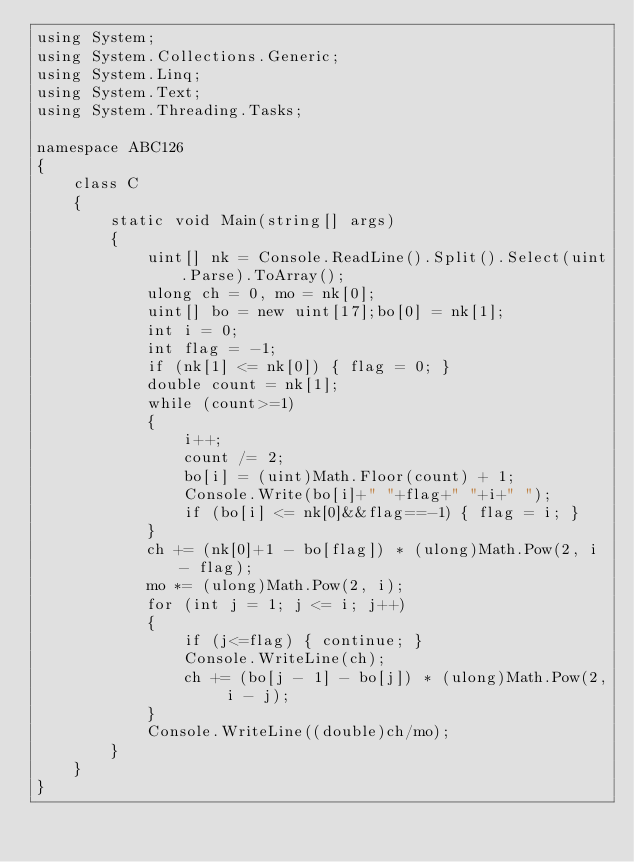<code> <loc_0><loc_0><loc_500><loc_500><_C#_>using System;
using System.Collections.Generic;
using System.Linq;
using System.Text;
using System.Threading.Tasks;

namespace ABC126
{
    class C
    {
        static void Main(string[] args)
        {
            uint[] nk = Console.ReadLine().Split().Select(uint.Parse).ToArray();
            ulong ch = 0, mo = nk[0];
            uint[] bo = new uint[17];bo[0] = nk[1];
            int i = 0;
            int flag = -1;
            if (nk[1] <= nk[0]) { flag = 0; }
            double count = nk[1];
            while (count>=1)
            {
                i++;
                count /= 2;
                bo[i] = (uint)Math.Floor(count) + 1;
                Console.Write(bo[i]+" "+flag+" "+i+" ");
                if (bo[i] <= nk[0]&&flag==-1) { flag = i; }
            }
            ch += (nk[0]+1 - bo[flag]) * (ulong)Math.Pow(2, i - flag);
            mo *= (ulong)Math.Pow(2, i);
            for (int j = 1; j <= i; j++)
            {
                if (j<=flag) { continue; }
                Console.WriteLine(ch);
                ch += (bo[j - 1] - bo[j]) * (ulong)Math.Pow(2, i - j);
            }
            Console.WriteLine((double)ch/mo);
        }
    }
}
</code> 